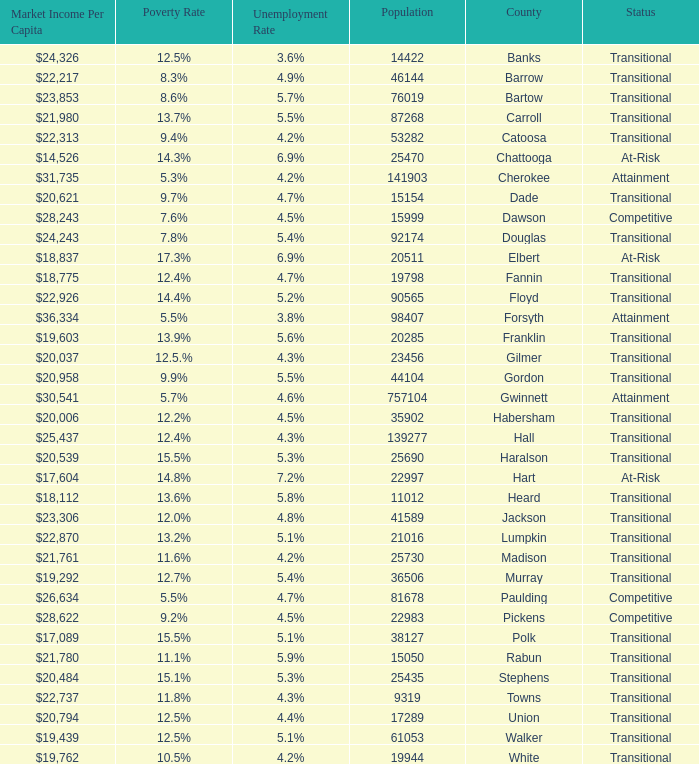How many status' are there with a population of 90565? 1.0. 